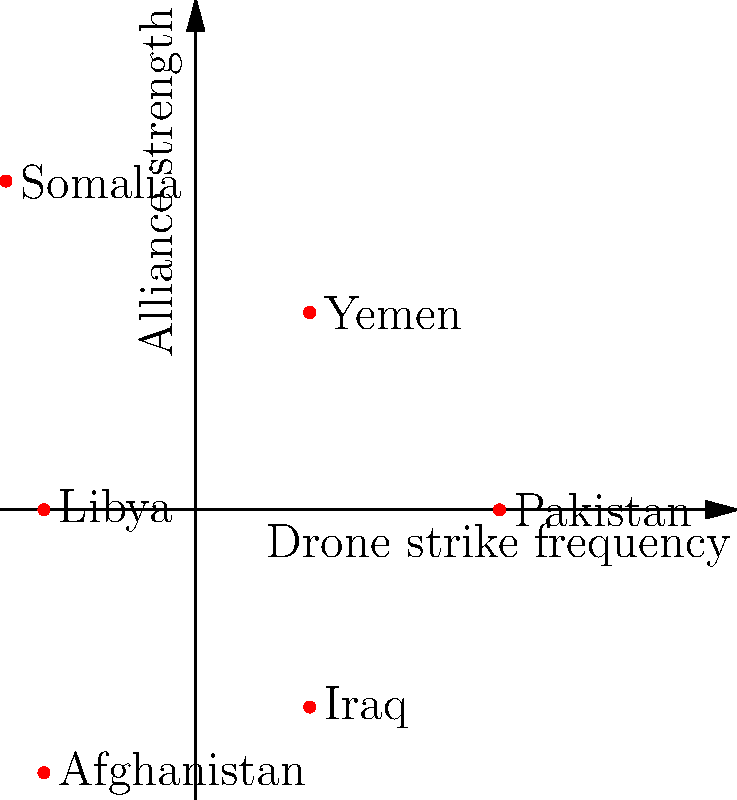Based on the polar coordinate graph representing drone strike frequency (radial distance) and alliance strength with the U.S. (angular position), which country shows the highest frequency of drone strikes while maintaining a relatively strong alliance? To answer this question, we need to analyze the polar coordinate graph:

1. The radial distance from the center represents the frequency of drone strikes.
2. The angular position represents the strength of the alliance with the U.S., with countries closer to the positive x-axis having stronger alliances.

Let's examine each country:

1. Pakistan: High frequency (radius ≈ 4), strong alliance (close to x-axis)
2. Yemen: Moderate frequency (radius ≈ 3), moderately strong alliance
3. Somalia: Highest frequency (radius ≈ 5), moderate alliance
4. Libya: Low frequency (radius ≈ 2), weak alliance
5. Afghanistan: High frequency (radius ≈ 4), weak alliance
6. Iraq: Moderate frequency (radius ≈ 3), weak alliance

Among these, Pakistan stands out as having a high frequency of drone strikes (second highest after Somalia) while maintaining a strong alliance with the U.S. (closest to the positive x-axis).

Somalia has the highest frequency but a weaker alliance compared to Pakistan. Other countries either have lower frequencies or weaker alliances.
Answer: Pakistan 